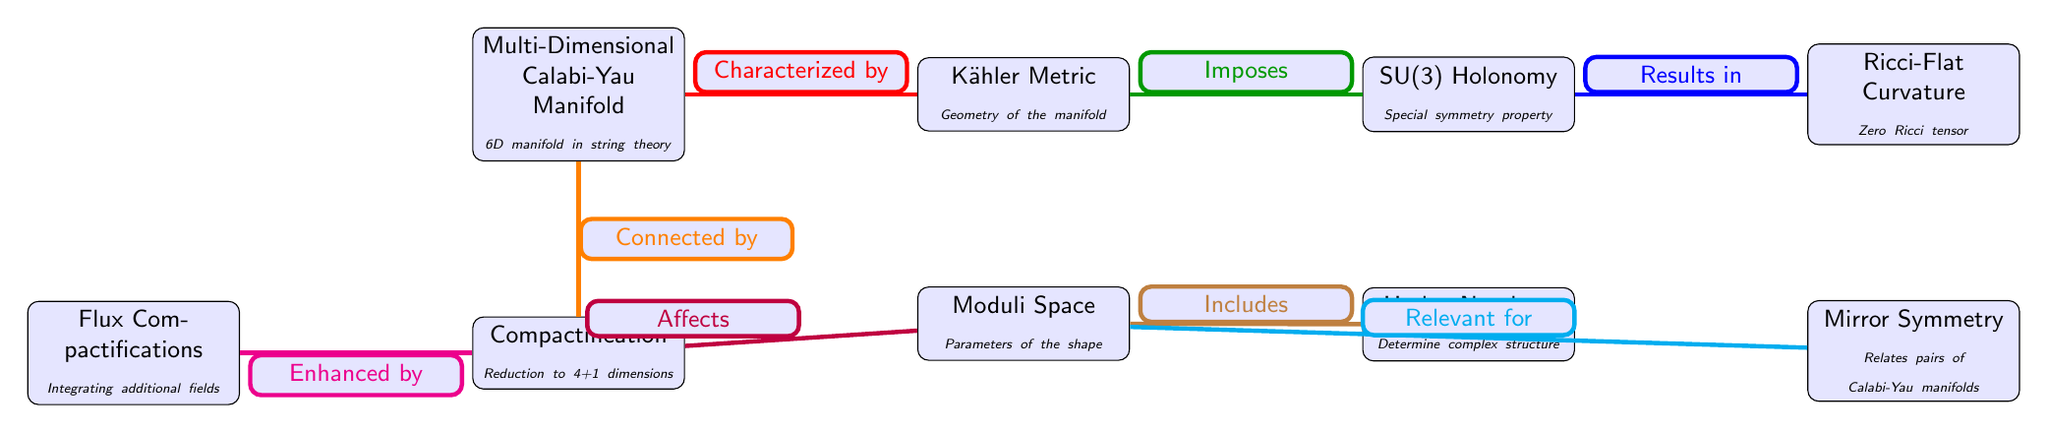What is the type of manifold depicted? The diagram explicitly states that the manifold is a "Multi-Dimensional Calabi-Yau Manifold" in string theory.
Answer: Multi-Dimensional Calabi-Yau Manifold How many nodes are present in the diagram? The diagram contains a total of eight nodes, which include the main components of the Calabi-Yau manifold and associated concepts.
Answer: 8 What does compactification reduce dimensions to? The "Compactification" node in the diagram states that it reduces dimensions to "4+1," indicating a five-dimensional space.
Answer: 4+1 What type of curvature is associated with the manifold? The diagram shows that the "Ricci-Flat Curvature" is a characteristic associated with the Calabi-Yau manifold.
Answer: Ricci-Flat Curvature What affects the moduli space? According to the diagram, the "Compactification" directly affects the "Moduli Space," highlighting their interconnectedness.
Answer: Compactification What is mirror symmetry relevant for? The diagram indicates that "Mirror Symmetry" is relevant for understanding pairs of Calabi-Yau manifolds, as shown in the relationship between the "Moduli Space" and "Mirror Symmetry."
Answer: Mirror Symmetry Which metric characterizes the manifold? From the diagram, it is clear that the "Kähler Metric" characterizes the geometry of the manifold.
Answer: Kähler Metric What symmetry property is associated with holonomy? The diagram specifies that the holonomy of the manifold is described by "SU(3)," indicating the specific symmetry associated with the geometry.
Answer: SU(3) Holonomy What do Hodge numbers determine? According to the diagram, "Hodge Numbers" serve to determine the complex structure of the Calabi-Yau manifold.
Answer: Complex structure 